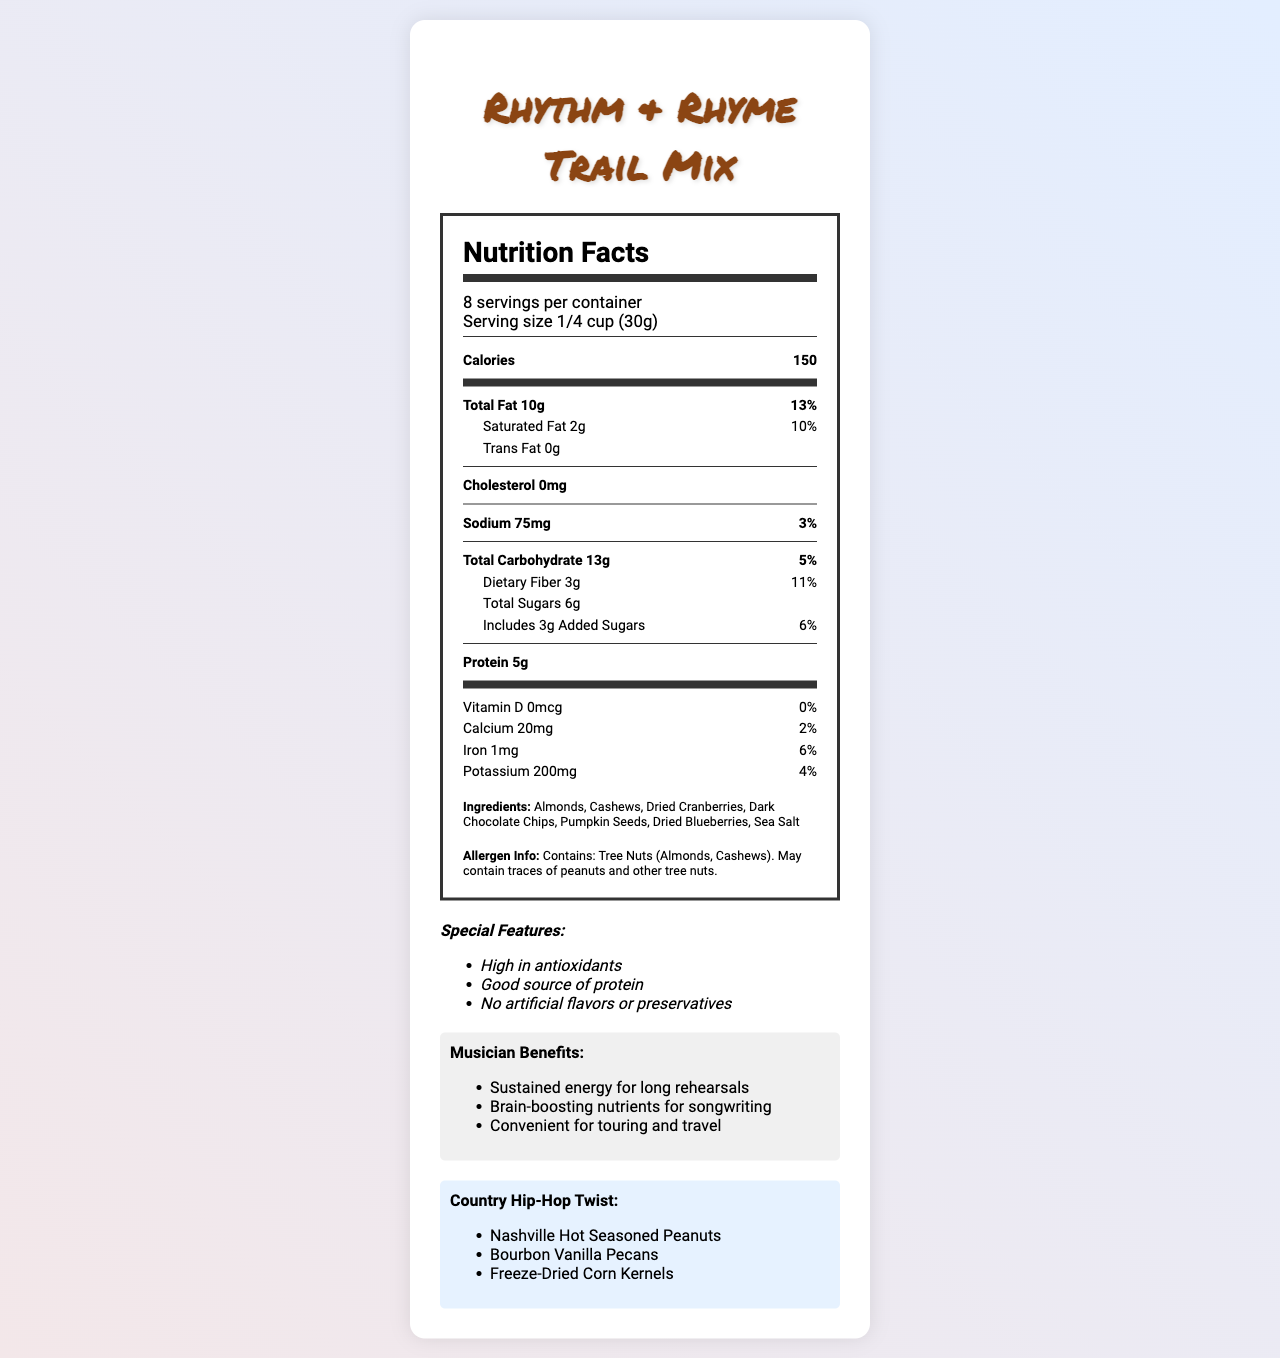what is the product name? The product name is prominently displayed at the top of the document.
Answer: Rhythm & Rhyme Trail Mix what is the serving size? The serving size is mentioned under the serving information section.
Answer: 1/4 cup (30g) how many servings are in one container? The document states "8 servings per container" in the serving information section.
Answer: 8 how many grams of protein are in one serving? The amount of protein per serving is listed as 5g in the nutrient information.
Answer: 5g what is the amount of total sugars per serving? The amount of total sugars per serving is detailed under the carbohydrate section in the nutrition label.
Answer: 6g what is the daily value percentage of calcium per serving? The daily value percentage for calcium is provided in the vitamin and mineral section.
Answer: 2% what ingredient gives a country-hip hop twist of Nashville Hot flavor? Nashville Hot Seasoned Peanuts are listed under the country-hip hop twist section.
Answer: Peanuts how much dietary fiber does each serving contain? A. 1g B. 2g C. 3g D. 4g The document specifies that each serving contains 3g of dietary fiber.
Answer: C what is the total fat content per serving? A. 8g B. 9g C. 10g D. 11g The total fat content per serving is stated as 10g in the nutrient information.
Answer: C are there any artificial flavors or preservatives in the product? The special features section mentions "No artificial flavors or preservatives".
Answer: No does this trail mix contain tree nuts? The allergen info states that the product contains tree nuts (Almonds, Cashews).
Answer: Yes summarize the main benefits of the Rhythm & Rhyme Trail Mix for musicians. The musician benefits section lists these three main benefits for musicians.
Answer: Sustained energy for long rehearsals, Brain-boosting nutrients for songwriting, Convenient for touring and travel what is the main idea of the document? The document's main sections include nutrition facts, ingredients, allergen info, special features, musician benefits, and a unique country-hip hop twist.
Answer: The document provides detailed nutrition information about the Rhythm & Rhyme Trail Mix designed for on-the-go musicians, highlighting its ingredients, special features, musician benefits, and a country-hip hop twist. how many grams of trans fat are in one serving? The document mentions that there is 0g of trans fat per serving.
Answer: 0g is there any cholesterol in this trail mix? The cholesterol amount is listed as 0mg.
Answer: No who is the manufacturer of the Rhythm & Rhyme Trail Mix? The document does not provide any details about the manufacturer.
Answer: Not enough information 